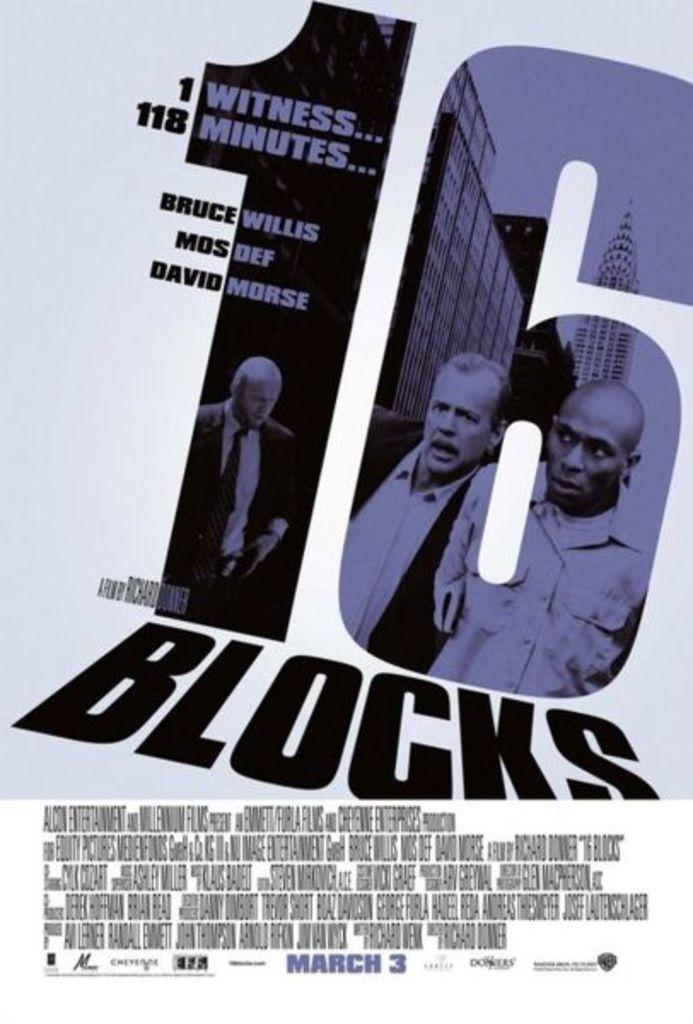Describe this image in one or two sentences. In this image it looks like a poster where we can see there is a number in the middle. At the bottom there is some text. In the number we can see there are two men. Behind the men there are buildings. 